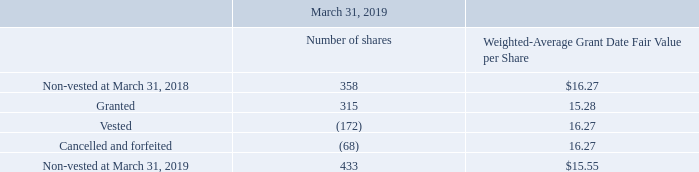13. Stock-Based Compensation:
Under the 2014 RSU Plan, we may grant restricted stock units of up to an aggregate of 3,000 units. Each unit converts to one share of the Company’s stock at the
time of vesting. The fair value of RSU awards is determined at the closing market price of the Company’s common stock at the date of grant. For the years ended March
31, 2018 and 2019, there were 292 and 315 awards, respectively, granted from this plan. Restricted stock activity during the year ended 2019 is as follows:
Performance-based awards vest one year after the grant date. Service-based awards vest as to one-third annually with the requisite service periods beginning on
the grant date. Awards are amortized over their respective grade-vesting periods. The total unrecognized compensation costs related to unvested stock awards expected
to be recognized over the vesting period, approximately three years, was $1,476 at March 31, 2019.
We have four fixed stock option plans. Under the 2004 Stock Option Plan, as amended, we may grant options to employees for the purchase of up to an aggregate
of 10,000 shares of common stock. Under the 2004 Non-Employee Directors’ Stock Option Plan, as amended, we may grant options for the purchase of up to an
aggregate of 1,000 shares of common stock. No awards were made under these two plans after August 1, 2013. Under the 2014 Stock Option Plan, we can grant options
to employees for the purchase of up to an aggregate of 10,000 shares of common stock. Under the 2014 Non-Employee Directors’ Stock Option Plan, as amended, we can
grant options to our directors for the purchase of up to an aggregate of 1,000 shares of common stock. Under all plans, the exercise price of each option shall not be less
than the market price of our stock on the date of grant and an option’s maximum term is 10 years. Options granted under the 2004 Stock Option Plan and the 2014 Stock
Option Plan vest as to 25% annually and options granted under the 2004 Non-Employee Directors’ Stock Option Plan and the 2014 Non-Employee Director’s Stock
Option Plan vest as to one-third annually. Requisite service periods related to all plans begin on the grant date. As of March 31, 2019, there were 12,447 shares of
common stock available for future issuance under all of the plans, consisting of options available to be granted and options currently outstanding.
What is the number of nonvested shares at March 31, 2018 and 2019 respectively? 358, 433. What is the number of options granted and vested respectively? 315, (172). What is the weighted average grant date fair value per share at March 31, 2018 and 2019 respectively? $16.27, $15.55. What is the percentage change in the weighted average grant date fair value per share between 2018 and 2019?
Answer scale should be: percent. (15.55-16.27)/16.27 
Answer: -4.43. What is the total unrecognised compensation costs related to unvested stock awards as a percentage of the value of nonvested shares at March 31, 2019? 
Answer scale should be: percent. 1,476/ (433 * 15.55) 
Answer: 21.92. What is the percentage change in the number of nonvested shares between March 31, 2018 and 2019? 
Answer scale should be: percent. (433 - 358)/358 
Answer: 20.95. 